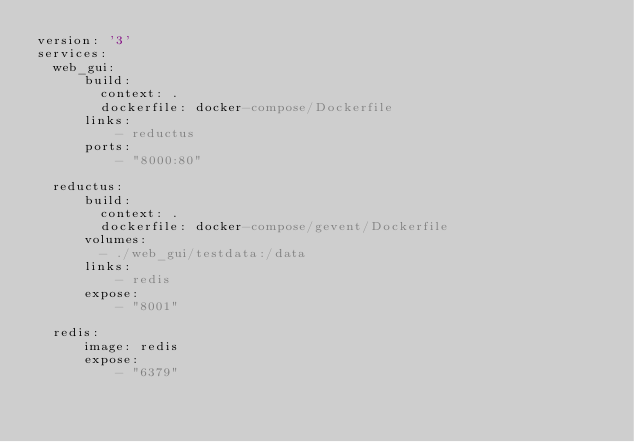<code> <loc_0><loc_0><loc_500><loc_500><_YAML_>version: '3'
services:
  web_gui:
      build:
        context: .
        dockerfile: docker-compose/Dockerfile
      links:
          - reductus
      ports:
          - "8000:80"

  reductus:
      build: 
        context: .
        dockerfile: docker-compose/gevent/Dockerfile
      volumes:
        - ./web_gui/testdata:/data
      links:
          - redis
      expose:
          - "8001"
          
  redis:
      image: redis
      expose:
          - "6379"
</code> 